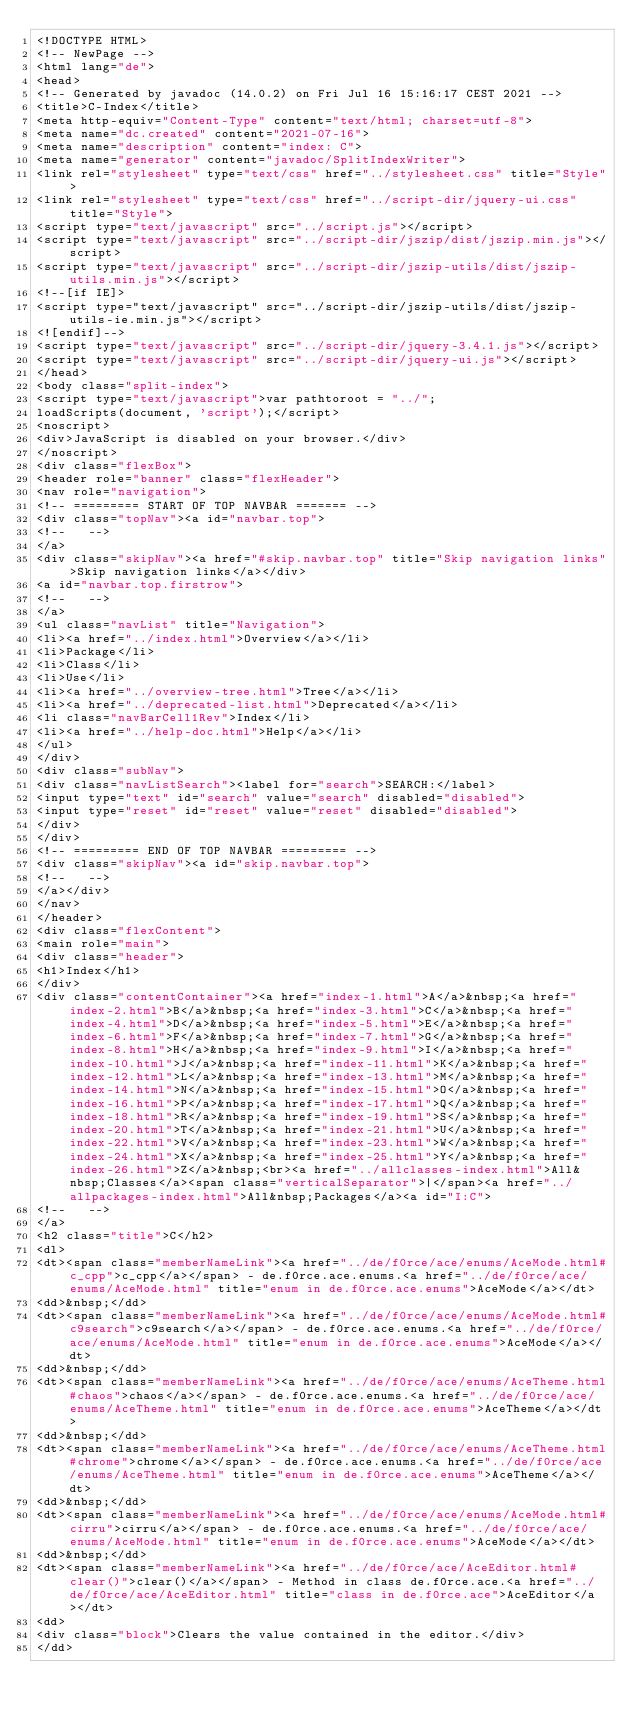Convert code to text. <code><loc_0><loc_0><loc_500><loc_500><_HTML_><!DOCTYPE HTML>
<!-- NewPage -->
<html lang="de">
<head>
<!-- Generated by javadoc (14.0.2) on Fri Jul 16 15:16:17 CEST 2021 -->
<title>C-Index</title>
<meta http-equiv="Content-Type" content="text/html; charset=utf-8">
<meta name="dc.created" content="2021-07-16">
<meta name="description" content="index: C">
<meta name="generator" content="javadoc/SplitIndexWriter">
<link rel="stylesheet" type="text/css" href="../stylesheet.css" title="Style">
<link rel="stylesheet" type="text/css" href="../script-dir/jquery-ui.css" title="Style">
<script type="text/javascript" src="../script.js"></script>
<script type="text/javascript" src="../script-dir/jszip/dist/jszip.min.js"></script>
<script type="text/javascript" src="../script-dir/jszip-utils/dist/jszip-utils.min.js"></script>
<!--[if IE]>
<script type="text/javascript" src="../script-dir/jszip-utils/dist/jszip-utils-ie.min.js"></script>
<![endif]-->
<script type="text/javascript" src="../script-dir/jquery-3.4.1.js"></script>
<script type="text/javascript" src="../script-dir/jquery-ui.js"></script>
</head>
<body class="split-index">
<script type="text/javascript">var pathtoroot = "../";
loadScripts(document, 'script');</script>
<noscript>
<div>JavaScript is disabled on your browser.</div>
</noscript>
<div class="flexBox">
<header role="banner" class="flexHeader">
<nav role="navigation">
<!-- ========= START OF TOP NAVBAR ======= -->
<div class="topNav"><a id="navbar.top">
<!--   -->
</a>
<div class="skipNav"><a href="#skip.navbar.top" title="Skip navigation links">Skip navigation links</a></div>
<a id="navbar.top.firstrow">
<!--   -->
</a>
<ul class="navList" title="Navigation">
<li><a href="../index.html">Overview</a></li>
<li>Package</li>
<li>Class</li>
<li>Use</li>
<li><a href="../overview-tree.html">Tree</a></li>
<li><a href="../deprecated-list.html">Deprecated</a></li>
<li class="navBarCell1Rev">Index</li>
<li><a href="../help-doc.html">Help</a></li>
</ul>
</div>
<div class="subNav">
<div class="navListSearch"><label for="search">SEARCH:</label>
<input type="text" id="search" value="search" disabled="disabled">
<input type="reset" id="reset" value="reset" disabled="disabled">
</div>
</div>
<!-- ========= END OF TOP NAVBAR ========= -->
<div class="skipNav"><a id="skip.navbar.top">
<!--   -->
</a></div>
</nav>
</header>
<div class="flexContent">
<main role="main">
<div class="header">
<h1>Index</h1>
</div>
<div class="contentContainer"><a href="index-1.html">A</a>&nbsp;<a href="index-2.html">B</a>&nbsp;<a href="index-3.html">C</a>&nbsp;<a href="index-4.html">D</a>&nbsp;<a href="index-5.html">E</a>&nbsp;<a href="index-6.html">F</a>&nbsp;<a href="index-7.html">G</a>&nbsp;<a href="index-8.html">H</a>&nbsp;<a href="index-9.html">I</a>&nbsp;<a href="index-10.html">J</a>&nbsp;<a href="index-11.html">K</a>&nbsp;<a href="index-12.html">L</a>&nbsp;<a href="index-13.html">M</a>&nbsp;<a href="index-14.html">N</a>&nbsp;<a href="index-15.html">O</a>&nbsp;<a href="index-16.html">P</a>&nbsp;<a href="index-17.html">Q</a>&nbsp;<a href="index-18.html">R</a>&nbsp;<a href="index-19.html">S</a>&nbsp;<a href="index-20.html">T</a>&nbsp;<a href="index-21.html">U</a>&nbsp;<a href="index-22.html">V</a>&nbsp;<a href="index-23.html">W</a>&nbsp;<a href="index-24.html">X</a>&nbsp;<a href="index-25.html">Y</a>&nbsp;<a href="index-26.html">Z</a>&nbsp;<br><a href="../allclasses-index.html">All&nbsp;Classes</a><span class="verticalSeparator">|</span><a href="../allpackages-index.html">All&nbsp;Packages</a><a id="I:C">
<!--   -->
</a>
<h2 class="title">C</h2>
<dl>
<dt><span class="memberNameLink"><a href="../de/f0rce/ace/enums/AceMode.html#c_cpp">c_cpp</a></span> - de.f0rce.ace.enums.<a href="../de/f0rce/ace/enums/AceMode.html" title="enum in de.f0rce.ace.enums">AceMode</a></dt>
<dd>&nbsp;</dd>
<dt><span class="memberNameLink"><a href="../de/f0rce/ace/enums/AceMode.html#c9search">c9search</a></span> - de.f0rce.ace.enums.<a href="../de/f0rce/ace/enums/AceMode.html" title="enum in de.f0rce.ace.enums">AceMode</a></dt>
<dd>&nbsp;</dd>
<dt><span class="memberNameLink"><a href="../de/f0rce/ace/enums/AceTheme.html#chaos">chaos</a></span> - de.f0rce.ace.enums.<a href="../de/f0rce/ace/enums/AceTheme.html" title="enum in de.f0rce.ace.enums">AceTheme</a></dt>
<dd>&nbsp;</dd>
<dt><span class="memberNameLink"><a href="../de/f0rce/ace/enums/AceTheme.html#chrome">chrome</a></span> - de.f0rce.ace.enums.<a href="../de/f0rce/ace/enums/AceTheme.html" title="enum in de.f0rce.ace.enums">AceTheme</a></dt>
<dd>&nbsp;</dd>
<dt><span class="memberNameLink"><a href="../de/f0rce/ace/enums/AceMode.html#cirru">cirru</a></span> - de.f0rce.ace.enums.<a href="../de/f0rce/ace/enums/AceMode.html" title="enum in de.f0rce.ace.enums">AceMode</a></dt>
<dd>&nbsp;</dd>
<dt><span class="memberNameLink"><a href="../de/f0rce/ace/AceEditor.html#clear()">clear()</a></span> - Method in class de.f0rce.ace.<a href="../de/f0rce/ace/AceEditor.html" title="class in de.f0rce.ace">AceEditor</a></dt>
<dd>
<div class="block">Clears the value contained in the editor.</div>
</dd></code> 